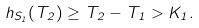<formula> <loc_0><loc_0><loc_500><loc_500>h _ { S _ { 1 } } ( T _ { 2 } ) \geq T _ { 2 } - T _ { 1 } > K _ { 1 } .</formula> 